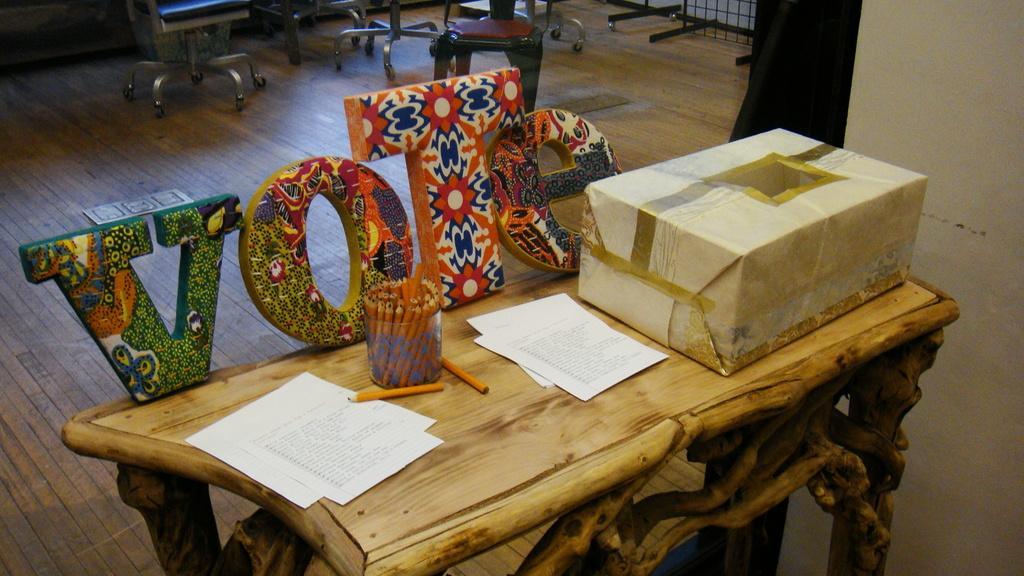How would you summarize this image in a sentence or two? In this image i can see there is a table with a box on it. I can also see there are few stools on the floor. 